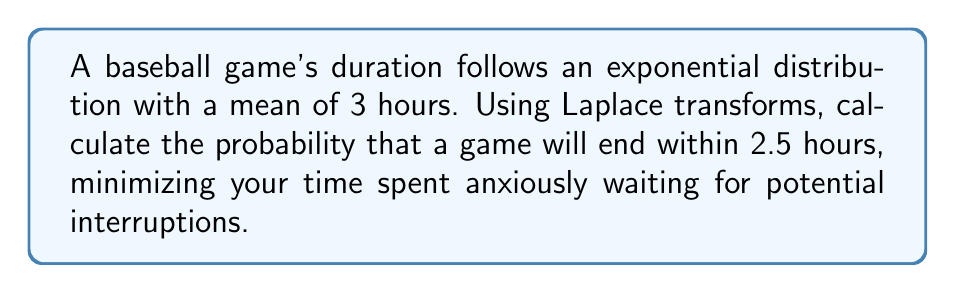Could you help me with this problem? Let's approach this step-by-step using Laplace transforms:

1) The probability density function (PDF) for an exponential distribution is:
   $$f(t) = \lambda e^{-\lambda t}$$
   where $\lambda$ is the rate parameter.

2) Given the mean is 3 hours, we can find $\lambda$:
   $$\frac{1}{\lambda} = 3 \implies \lambda = \frac{1}{3}$$

3) The cumulative distribution function (CDF) gives the probability that the game ends within time $t$:
   $$F(t) = P(T \leq t) = 1 - e^{-\lambda t}$$

4) We could directly calculate $F(2.5)$, but let's use Laplace transforms as requested.

5) The Laplace transform of $f(t)$ is:
   $$\mathcal{L}\{f(t)\} = F(s) = \frac{\lambda}{s + \lambda}$$

6) Substituting $\lambda = \frac{1}{3}$:
   $$F(s) = \frac{\frac{1}{3}}{s + \frac{1}{3}}$$

7) To find the CDF, we need the inverse Laplace transform of $\frac{F(s)}{s}$:
   $$\mathcal{L}^{-1}\left\{\frac{F(s)}{s}\right\} = \mathcal{L}^{-1}\left\{\frac{\frac{1}{3}}{s(s + \frac{1}{3})}\right\}$$

8) Using partial fraction decomposition:
   $$\frac{\frac{1}{3}}{s(s + \frac{1}{3})} = \frac{1}{s} - \frac{1}{s + \frac{1}{3}}$$

9) Taking the inverse Laplace transform:
   $$\mathcal{L}^{-1}\left\{\frac{1}{s} - \frac{1}{s + \frac{1}{3}}\right\} = 1 - e^{-\frac{1}{3}t}$$

10) This is our CDF. To find the probability of the game ending within 2.5 hours:
    $$P(T \leq 2.5) = 1 - e^{-\frac{1}{3}(2.5)} = 1 - e^{-\frac{5}{6}}$$

11) Calculating this value:
    $$1 - e^{-\frac{5}{6}} \approx 0.5651$$
Answer: The probability that the baseball game will end within 2.5 hours is approximately 0.5651 or 56.51%. 